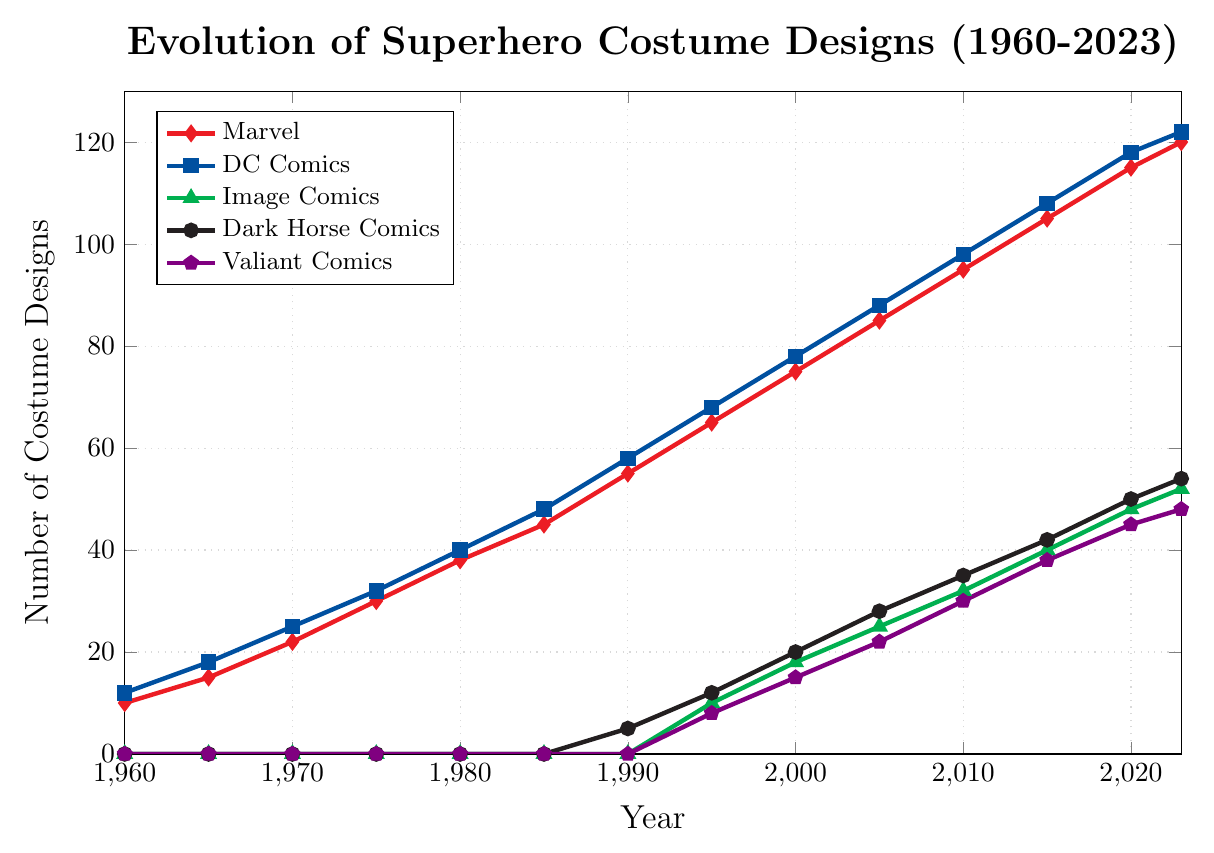Which comic brand had the slowest start in costume designs but eventually showed significant growth around 1995? Image Comics had no costume designs until 1995 but then showed significant growth starting from that year based on the line plot
Answer: Image Comics Between Marvel and DC Comics, which had a greater increase in costume designs from 1960 to 2023? By looking at the difference in costume designs between 1960 and 2023 for both brands, Marvel increased from 10 to 120 (an increase of 110), and DC Comics increased from 12 to 122 (an increase of 110). Both had the same increase
Answer: Both Marvel and DC Comics Which year did Dark Horse Comics first appear with costume designs? By observing when Dark Horse Comics starts showing up on the plot, it first appears in 1990 with 5 costume designs
Answer: 1990 What is the difference in the number of costume designs between Valiant Comics and Image Comics in 2023? By comparing the points for Valiant Comics (48) and Image Comics (52) in 2023 from the plot, the difference is 52 - 48
Answer: 4 In which year did Marvel and DC Comics have an equal number of costume designs? By searching for where the lines for Marvel and DC Comics intersect on the plot, it can be observed that their values never meet exactly at the same point
Answer: Never Which comic brand had the sharpest increase in costume designs from 2000 to 2005? By examining the slopes of the lines between 2000 and 2005, Marvel's designs go from 75 to 85 (increase of 10), DC Comics from 78 to 88 (increase of 10), Image Comics from 18 to 25 (increase of 7), Dark Horse Comics from 20 to 28 (increase of 8), and Valiant Comics from 15 to 22 (increase of 7). Both Marvel and DC Comics had the sharpest increase
Answer: Both Marvel and DC Comics How many more costume designs did Marvel have compared to Dark Horse Comics in 2010? Marvel had 95 designs and Dark Horse Comics had 35 designs in 2010, so the difference is 95 - 35
Answer: 60 What color represents DC Comics on the plot? By looking at the legend, DC Comics is represented by the color blue
Answer: Blue What is the average number of costume designs for Marvel in the years 1960, 1980, and 2000? The values for Marvel in these years are 10 in 1960, 38 in 1980, and 75 in 2000. The average is calculated as (10 + 38 + 75) / 3
Answer: 41 Which two comic brands had overlapping costume design counts in 2005? By comparing the values in 2005, no two brands have the same number of costume designs in that year
Answer: None 